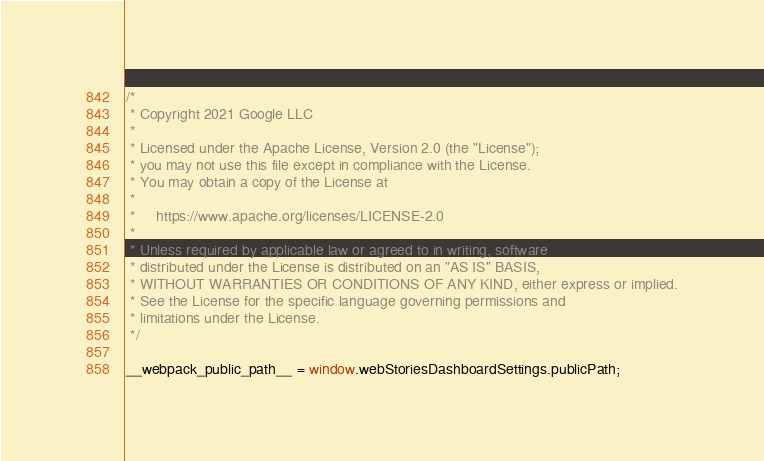<code> <loc_0><loc_0><loc_500><loc_500><_JavaScript_>/*
 * Copyright 2021 Google LLC
 *
 * Licensed under the Apache License, Version 2.0 (the "License");
 * you may not use this file except in compliance with the License.
 * You may obtain a copy of the License at
 *
 *     https://www.apache.org/licenses/LICENSE-2.0
 *
 * Unless required by applicable law or agreed to in writing, software
 * distributed under the License is distributed on an "AS IS" BASIS,
 * WITHOUT WARRANTIES OR CONDITIONS OF ANY KIND, either express or implied.
 * See the License for the specific language governing permissions and
 * limitations under the License.
 */

__webpack_public_path__ = window.webStoriesDashboardSettings.publicPath;
</code> 